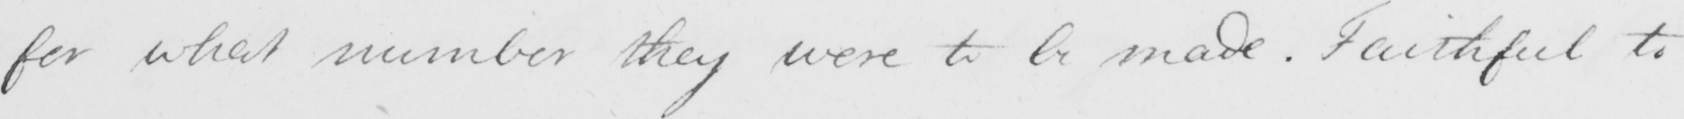Please provide the text content of this handwritten line. for what number they were to be made . Faithful to 